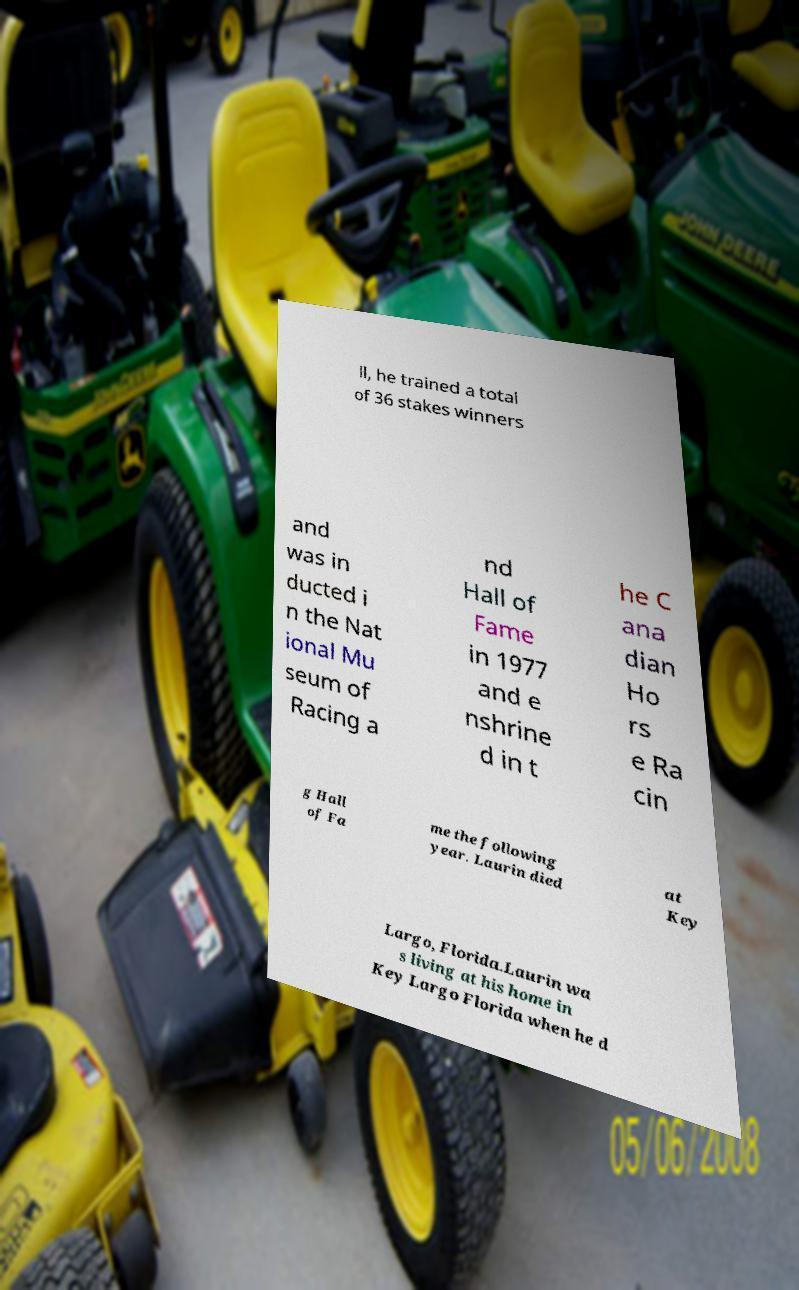Please read and relay the text visible in this image. What does it say? ll, he trained a total of 36 stakes winners and was in ducted i n the Nat ional Mu seum of Racing a nd Hall of Fame in 1977 and e nshrine d in t he C ana dian Ho rs e Ra cin g Hall of Fa me the following year. Laurin died at Key Largo, Florida.Laurin wa s living at his home in Key Largo Florida when he d 